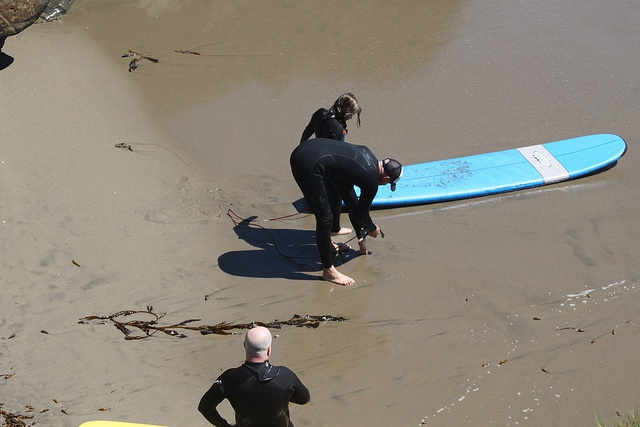Describe the objects in this image and their specific colors. I can see surfboard in gray, lightblue, and white tones, people in gray and black tones, people in gray, black, darkgray, and lightgray tones, and people in gray, black, and darkgray tones in this image. 